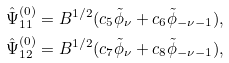Convert formula to latex. <formula><loc_0><loc_0><loc_500><loc_500>\hat { \Psi } _ { 1 1 } ^ { ( 0 ) } = B ^ { 1 / 2 } ( c _ { 5 } \tilde { \phi } _ { \nu } + c _ { 6 } \tilde { \phi } _ { - \nu - 1 } ) , \\ \hat { \Psi } _ { 1 2 } ^ { ( 0 ) } = B ^ { 1 / 2 } ( c _ { 7 } \tilde { \phi } _ { \nu } + c _ { 8 } \tilde { \phi } _ { - \nu - 1 } ) ,</formula> 